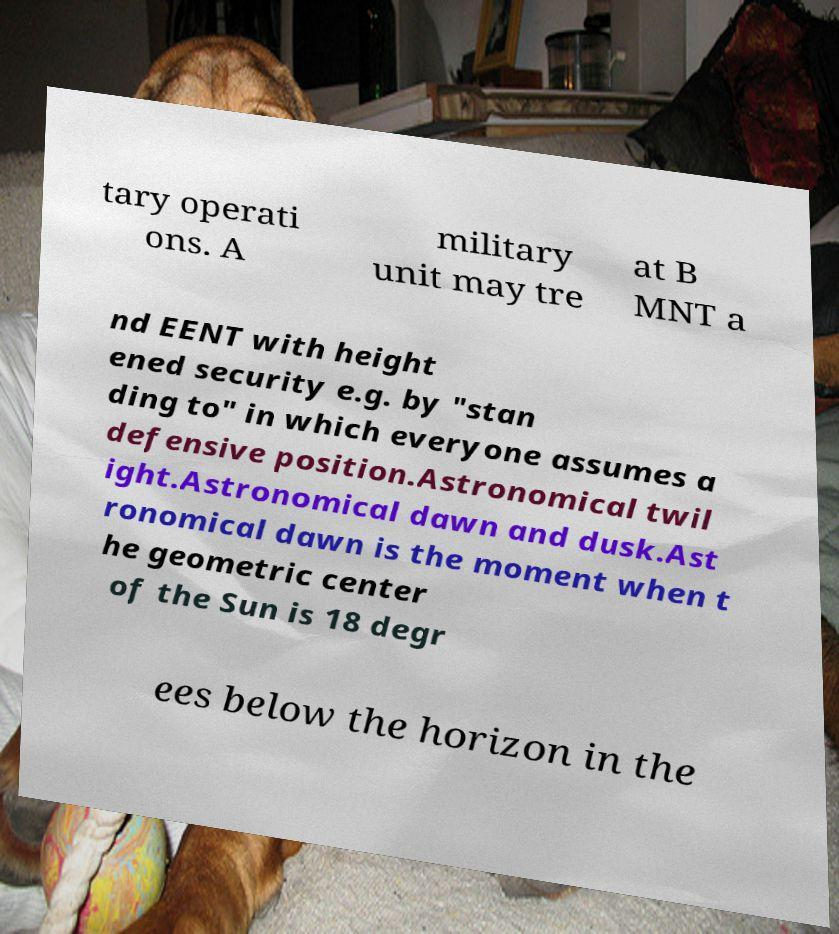Please identify and transcribe the text found in this image. tary operati ons. A military unit may tre at B MNT a nd EENT with height ened security e.g. by "stan ding to" in which everyone assumes a defensive position.Astronomical twil ight.Astronomical dawn and dusk.Ast ronomical dawn is the moment when t he geometric center of the Sun is 18 degr ees below the horizon in the 